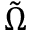<formula> <loc_0><loc_0><loc_500><loc_500>\tilde { \Omega }</formula> 